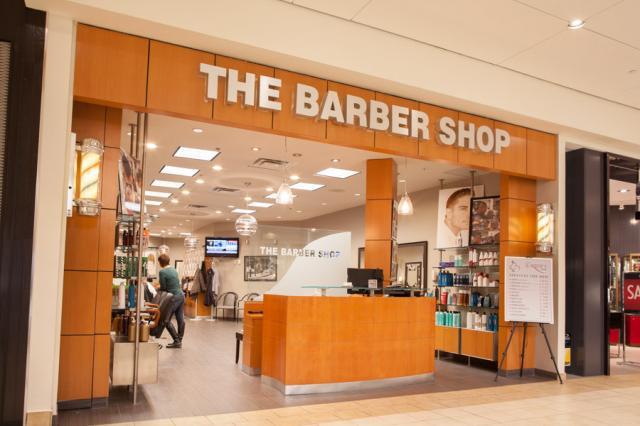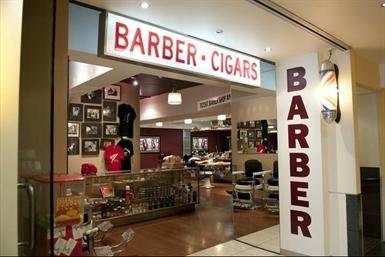The first image is the image on the left, the second image is the image on the right. Assess this claim about the two images: "There is a barber pole in the image on the right.". Correct or not? Answer yes or no. No. 